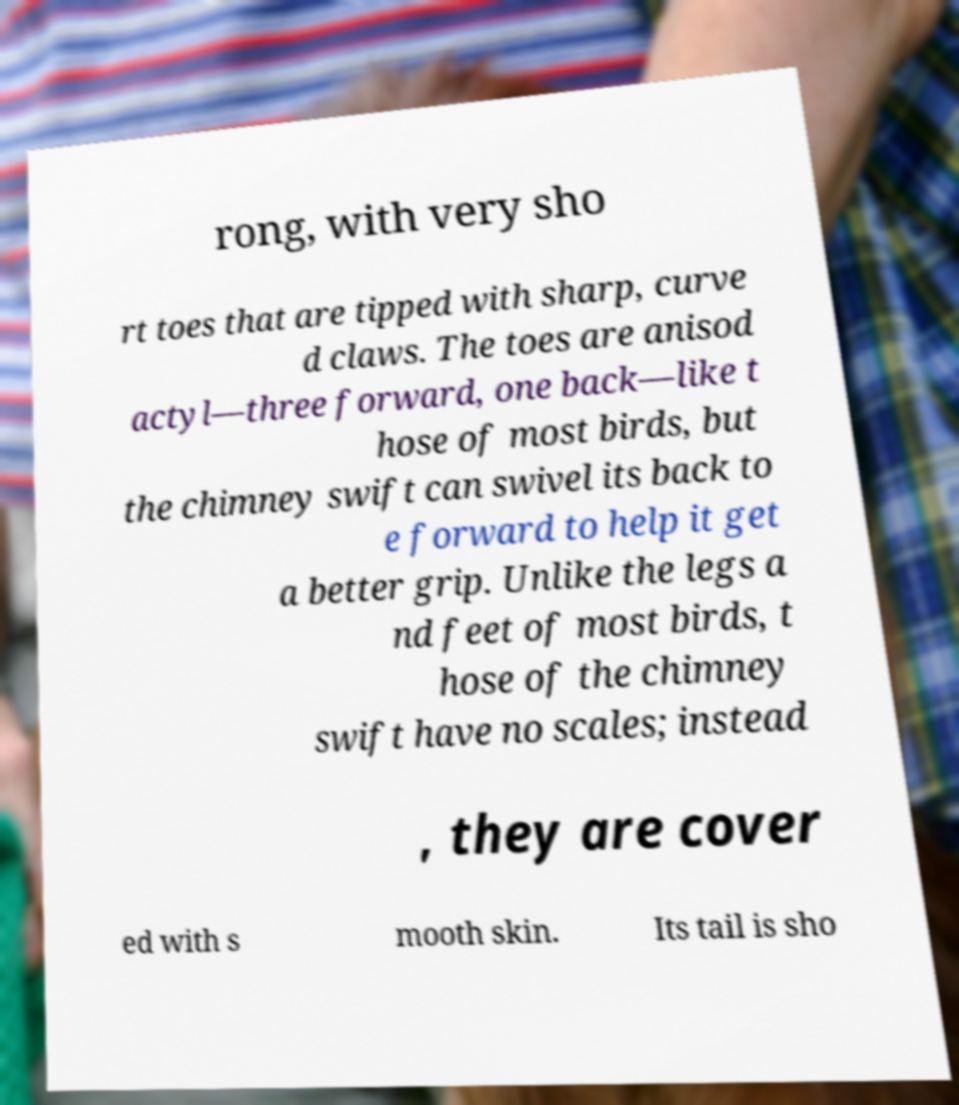I need the written content from this picture converted into text. Can you do that? rong, with very sho rt toes that are tipped with sharp, curve d claws. The toes are anisod actyl—three forward, one back—like t hose of most birds, but the chimney swift can swivel its back to e forward to help it get a better grip. Unlike the legs a nd feet of most birds, t hose of the chimney swift have no scales; instead , they are cover ed with s mooth skin. Its tail is sho 